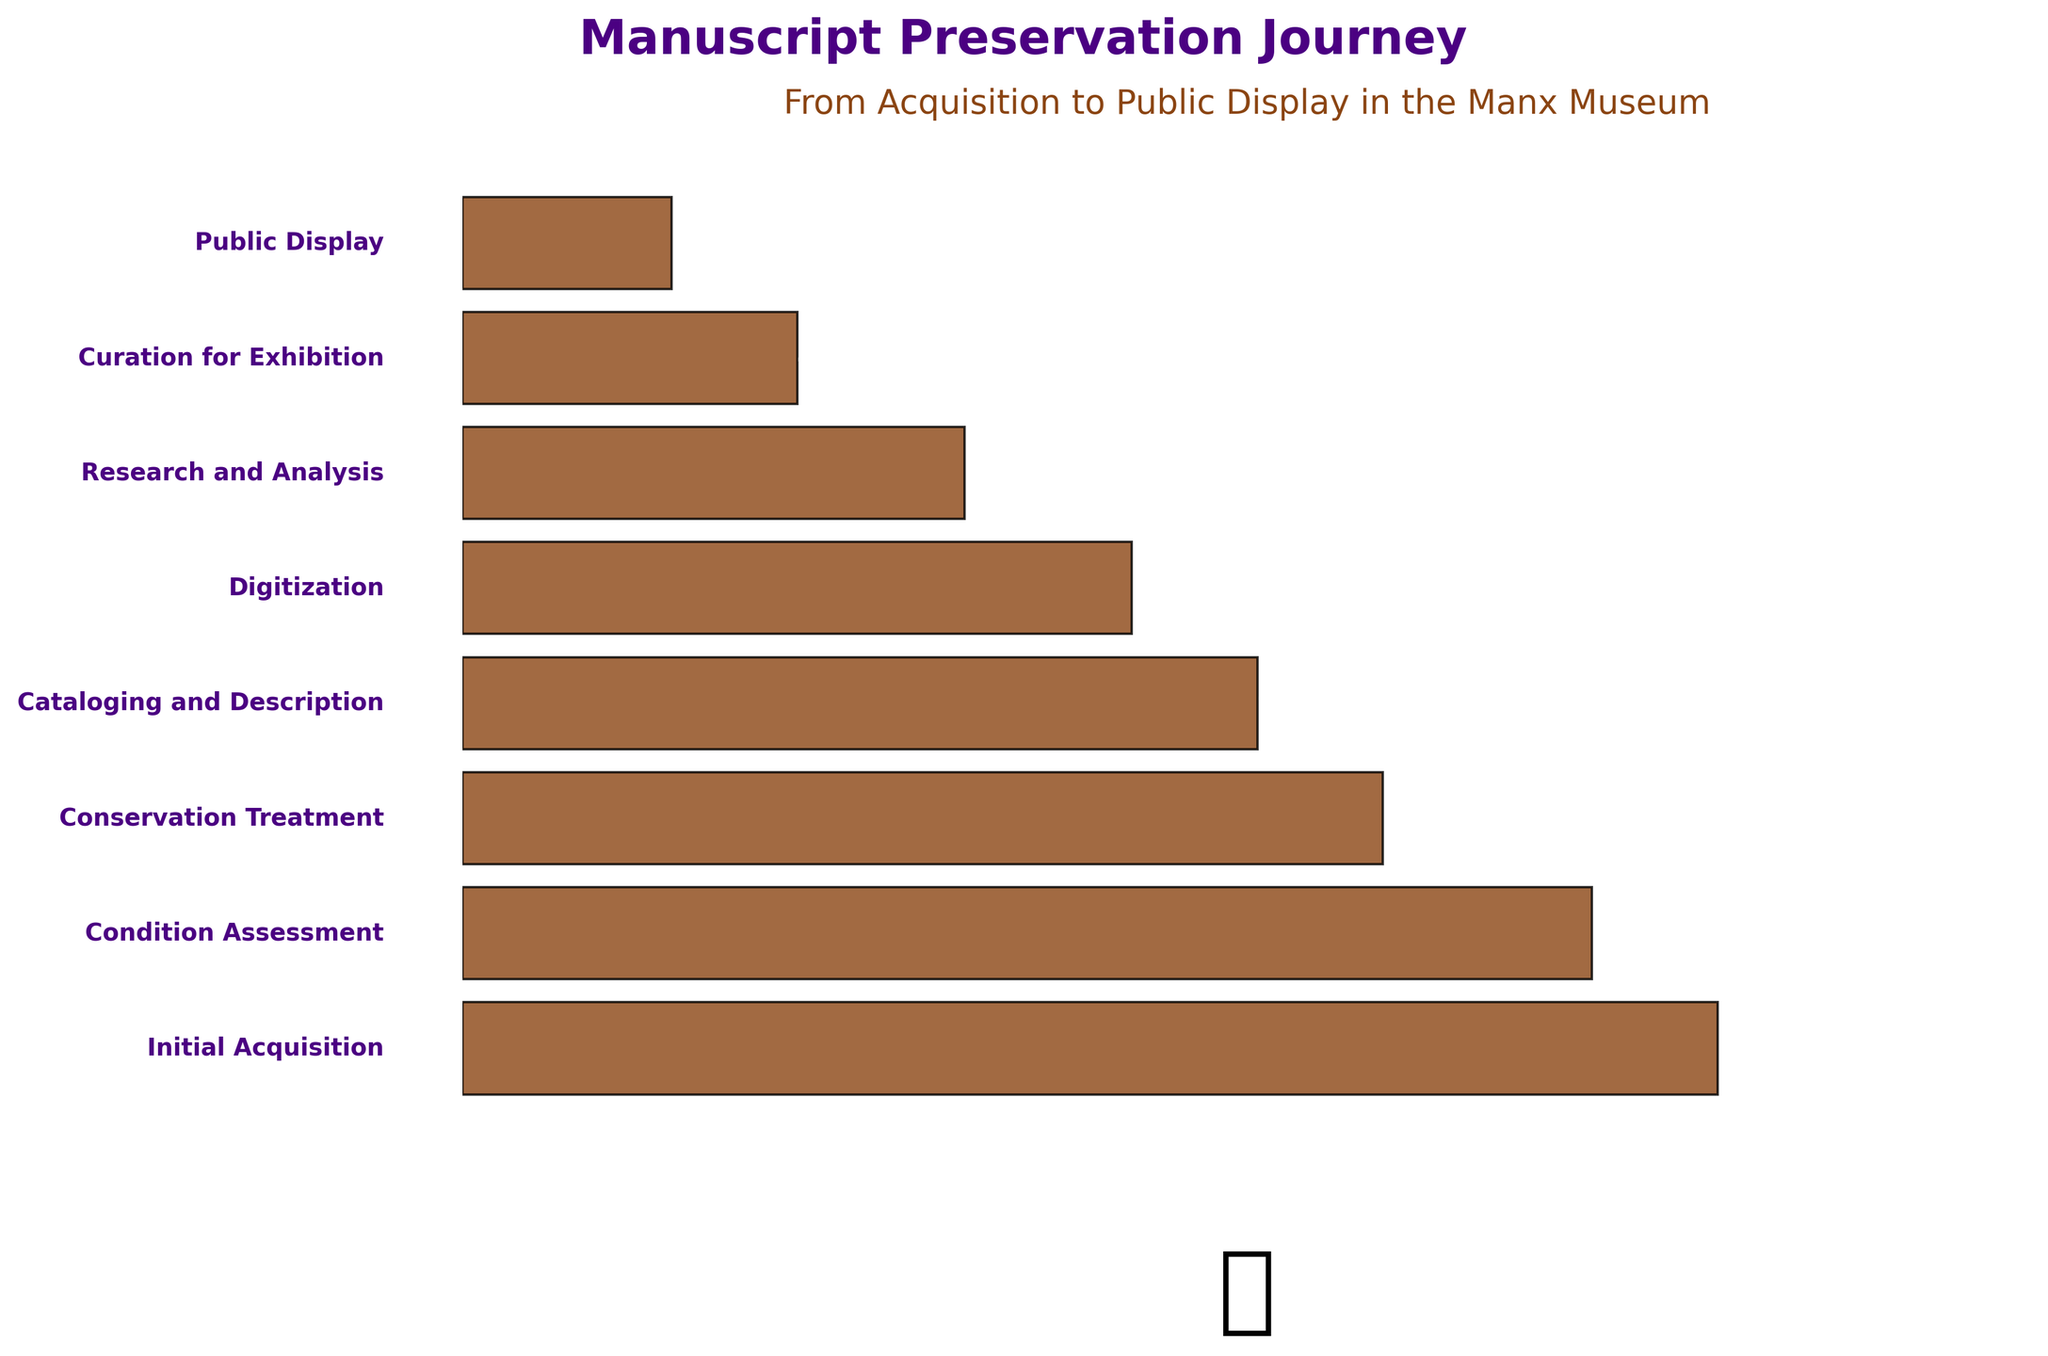What's the title of the figure? The title is usually prominently displayed at the top of the figure. In this case, it reads "Manuscript Preservation Journey" along with the subtitle "From Acquisition to Public Display in the Manx Museum."
Answer: Manuscript Preservation Journey Which stage has the highest number of manuscripts? The stage with the highest number is at the top of the funnel. In the chart, it’s the "Initial Acquisition" stage, which has 150 manuscripts.
Answer: Initial Acquisition How many stages are represented in the funnel chart? By counting the distinct segments of the bar in the funnel chart, we find that there are 8 stages in total.
Answer: 8 At which stage do we observe the largest decrease in the number of manuscripts? Comparing the differences between consecutive stages, the largest decrease occurs between "Digitization" (80 manuscripts) and "Research and Analysis" (60 manuscripts), which is a drop of 20 manuscripts.
Answer: Between Digitization and Research and Analysis What is the primary color used in the funnel chart? The primary color used for the funnel segments is a brownish shade, which complements the preservation theme.
Answer: Brown Which stage has nearly half the number of manuscripts compared to the Initial Acquisition phase? Approximately half of 150 manuscripts is 75. The "Digitization" stage has 80 manuscripts, which is closest to this value.
Answer: Digitization What is the total number of manuscripts from the "Conservation Treatment" to the "Public Display" stages? Sum the manuscripts from these stages: Conservation Treatment (110), Cataloging and Description (95), Digitization (80), Research and Analysis (60), Curation for Exhibition (40), and Public Display (25). 110 + 95 + 80 + 60 + 40 + 25 = 410 manuscripts.
Answer: 410 How many fewer manuscripts are displayed to the public compared to those acquired initially? Subtract the number of manuscripts in the "Public Display" stage (25) from those in the "Initial Acquisition" stage (150). 150 - 25 = 125 manuscripts.
Answer: 125 At which stage does the number of manuscripts first drop below 100? By observing the chart, the stage where the number of manuscripts first drops below 100 is "Cataloging and Description" with 95 manuscripts.
Answer: Cataloging and Description What decorative element is included at the bottom of the chart? There is a large decorative element, specifically an emoji of a scroll (📜), placed at the bottom center of the chart.
Answer: Scroll emoji (📜) 